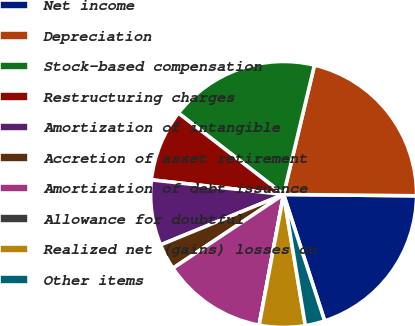Convert chart to OTSL. <chart><loc_0><loc_0><loc_500><loc_500><pie_chart><fcel>Net income<fcel>Depreciation<fcel>Stock-based compensation<fcel>Restructuring charges<fcel>Amortization of intangible<fcel>Accretion of asset retirement<fcel>Amortization of debt issuance<fcel>Allowance for doubtful<fcel>Realized net (gains) losses on<fcel>Other items<nl><fcel>19.84%<fcel>21.43%<fcel>18.25%<fcel>8.73%<fcel>7.94%<fcel>3.17%<fcel>12.7%<fcel>0.0%<fcel>5.56%<fcel>2.38%<nl></chart> 